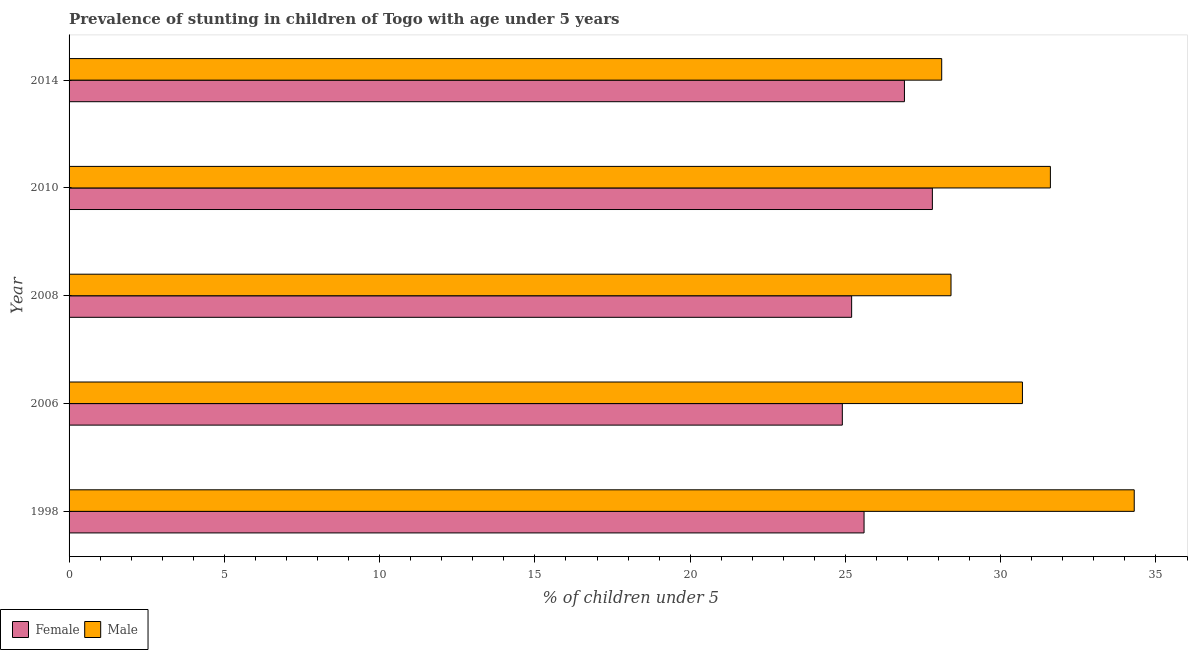How many different coloured bars are there?
Give a very brief answer. 2. How many groups of bars are there?
Offer a terse response. 5. Are the number of bars per tick equal to the number of legend labels?
Give a very brief answer. Yes. How many bars are there on the 3rd tick from the bottom?
Offer a very short reply. 2. What is the label of the 1st group of bars from the top?
Provide a short and direct response. 2014. In how many cases, is the number of bars for a given year not equal to the number of legend labels?
Offer a terse response. 0. What is the percentage of stunted male children in 2010?
Provide a short and direct response. 31.6. Across all years, what is the maximum percentage of stunted female children?
Provide a succinct answer. 27.8. Across all years, what is the minimum percentage of stunted female children?
Keep it short and to the point. 24.9. In which year was the percentage of stunted female children minimum?
Your response must be concise. 2006. What is the total percentage of stunted female children in the graph?
Provide a short and direct response. 130.4. What is the difference between the percentage of stunted female children in 1998 and the percentage of stunted male children in 2006?
Your response must be concise. -5.1. What is the average percentage of stunted male children per year?
Keep it short and to the point. 30.62. In the year 2014, what is the difference between the percentage of stunted male children and percentage of stunted female children?
Ensure brevity in your answer.  1.2. What is the ratio of the percentage of stunted female children in 1998 to that in 2010?
Give a very brief answer. 0.92. What is the difference between the highest and the second highest percentage of stunted female children?
Offer a terse response. 0.9. In how many years, is the percentage of stunted female children greater than the average percentage of stunted female children taken over all years?
Ensure brevity in your answer.  2. Is the sum of the percentage of stunted male children in 1998 and 2006 greater than the maximum percentage of stunted female children across all years?
Your answer should be compact. Yes. How many years are there in the graph?
Offer a terse response. 5. What is the difference between two consecutive major ticks on the X-axis?
Make the answer very short. 5. Are the values on the major ticks of X-axis written in scientific E-notation?
Offer a very short reply. No. Does the graph contain grids?
Provide a succinct answer. No. How many legend labels are there?
Give a very brief answer. 2. What is the title of the graph?
Give a very brief answer. Prevalence of stunting in children of Togo with age under 5 years. Does "Under-five" appear as one of the legend labels in the graph?
Provide a short and direct response. No. What is the label or title of the X-axis?
Give a very brief answer.  % of children under 5. What is the label or title of the Y-axis?
Provide a short and direct response. Year. What is the  % of children under 5 in Female in 1998?
Ensure brevity in your answer.  25.6. What is the  % of children under 5 in Male in 1998?
Provide a short and direct response. 34.3. What is the  % of children under 5 of Female in 2006?
Ensure brevity in your answer.  24.9. What is the  % of children under 5 in Male in 2006?
Your answer should be compact. 30.7. What is the  % of children under 5 in Female in 2008?
Provide a succinct answer. 25.2. What is the  % of children under 5 of Male in 2008?
Provide a short and direct response. 28.4. What is the  % of children under 5 in Female in 2010?
Your answer should be compact. 27.8. What is the  % of children under 5 in Male in 2010?
Provide a short and direct response. 31.6. What is the  % of children under 5 of Female in 2014?
Provide a short and direct response. 26.9. What is the  % of children under 5 of Male in 2014?
Offer a very short reply. 28.1. Across all years, what is the maximum  % of children under 5 of Female?
Your answer should be compact. 27.8. Across all years, what is the maximum  % of children under 5 in Male?
Ensure brevity in your answer.  34.3. Across all years, what is the minimum  % of children under 5 in Female?
Give a very brief answer. 24.9. Across all years, what is the minimum  % of children under 5 in Male?
Offer a terse response. 28.1. What is the total  % of children under 5 in Female in the graph?
Make the answer very short. 130.4. What is the total  % of children under 5 of Male in the graph?
Provide a succinct answer. 153.1. What is the difference between the  % of children under 5 of Female in 1998 and that in 2006?
Make the answer very short. 0.7. What is the difference between the  % of children under 5 in Female in 1998 and that in 2008?
Keep it short and to the point. 0.4. What is the difference between the  % of children under 5 of Female in 1998 and that in 2014?
Your answer should be compact. -1.3. What is the difference between the  % of children under 5 of Male in 1998 and that in 2014?
Offer a terse response. 6.2. What is the difference between the  % of children under 5 in Female in 2006 and that in 2008?
Make the answer very short. -0.3. What is the difference between the  % of children under 5 in Female in 2006 and that in 2014?
Make the answer very short. -2. What is the difference between the  % of children under 5 in Female in 2008 and that in 2010?
Your response must be concise. -2.6. What is the difference between the  % of children under 5 in Male in 2008 and that in 2010?
Your response must be concise. -3.2. What is the difference between the  % of children under 5 in Female in 2010 and that in 2014?
Make the answer very short. 0.9. What is the difference between the  % of children under 5 of Male in 2010 and that in 2014?
Your answer should be compact. 3.5. What is the difference between the  % of children under 5 in Female in 2006 and the  % of children under 5 in Male in 2014?
Offer a terse response. -3.2. What is the difference between the  % of children under 5 in Female in 2008 and the  % of children under 5 in Male in 2010?
Your answer should be compact. -6.4. What is the average  % of children under 5 of Female per year?
Keep it short and to the point. 26.08. What is the average  % of children under 5 in Male per year?
Keep it short and to the point. 30.62. What is the ratio of the  % of children under 5 in Female in 1998 to that in 2006?
Offer a terse response. 1.03. What is the ratio of the  % of children under 5 in Male in 1998 to that in 2006?
Your answer should be compact. 1.12. What is the ratio of the  % of children under 5 of Female in 1998 to that in 2008?
Your response must be concise. 1.02. What is the ratio of the  % of children under 5 of Male in 1998 to that in 2008?
Your answer should be compact. 1.21. What is the ratio of the  % of children under 5 of Female in 1998 to that in 2010?
Give a very brief answer. 0.92. What is the ratio of the  % of children under 5 of Male in 1998 to that in 2010?
Your answer should be very brief. 1.09. What is the ratio of the  % of children under 5 of Female in 1998 to that in 2014?
Make the answer very short. 0.95. What is the ratio of the  % of children under 5 of Male in 1998 to that in 2014?
Give a very brief answer. 1.22. What is the ratio of the  % of children under 5 of Male in 2006 to that in 2008?
Provide a short and direct response. 1.08. What is the ratio of the  % of children under 5 in Female in 2006 to that in 2010?
Your response must be concise. 0.9. What is the ratio of the  % of children under 5 of Male in 2006 to that in 2010?
Ensure brevity in your answer.  0.97. What is the ratio of the  % of children under 5 in Female in 2006 to that in 2014?
Give a very brief answer. 0.93. What is the ratio of the  % of children under 5 of Male in 2006 to that in 2014?
Offer a terse response. 1.09. What is the ratio of the  % of children under 5 of Female in 2008 to that in 2010?
Make the answer very short. 0.91. What is the ratio of the  % of children under 5 in Male in 2008 to that in 2010?
Offer a terse response. 0.9. What is the ratio of the  % of children under 5 of Female in 2008 to that in 2014?
Provide a short and direct response. 0.94. What is the ratio of the  % of children under 5 of Male in 2008 to that in 2014?
Provide a succinct answer. 1.01. What is the ratio of the  % of children under 5 in Female in 2010 to that in 2014?
Provide a succinct answer. 1.03. What is the ratio of the  % of children under 5 in Male in 2010 to that in 2014?
Provide a short and direct response. 1.12. What is the difference between the highest and the second highest  % of children under 5 in Female?
Your response must be concise. 0.9. What is the difference between the highest and the second highest  % of children under 5 of Male?
Keep it short and to the point. 2.7. What is the difference between the highest and the lowest  % of children under 5 of Female?
Provide a succinct answer. 2.9. 